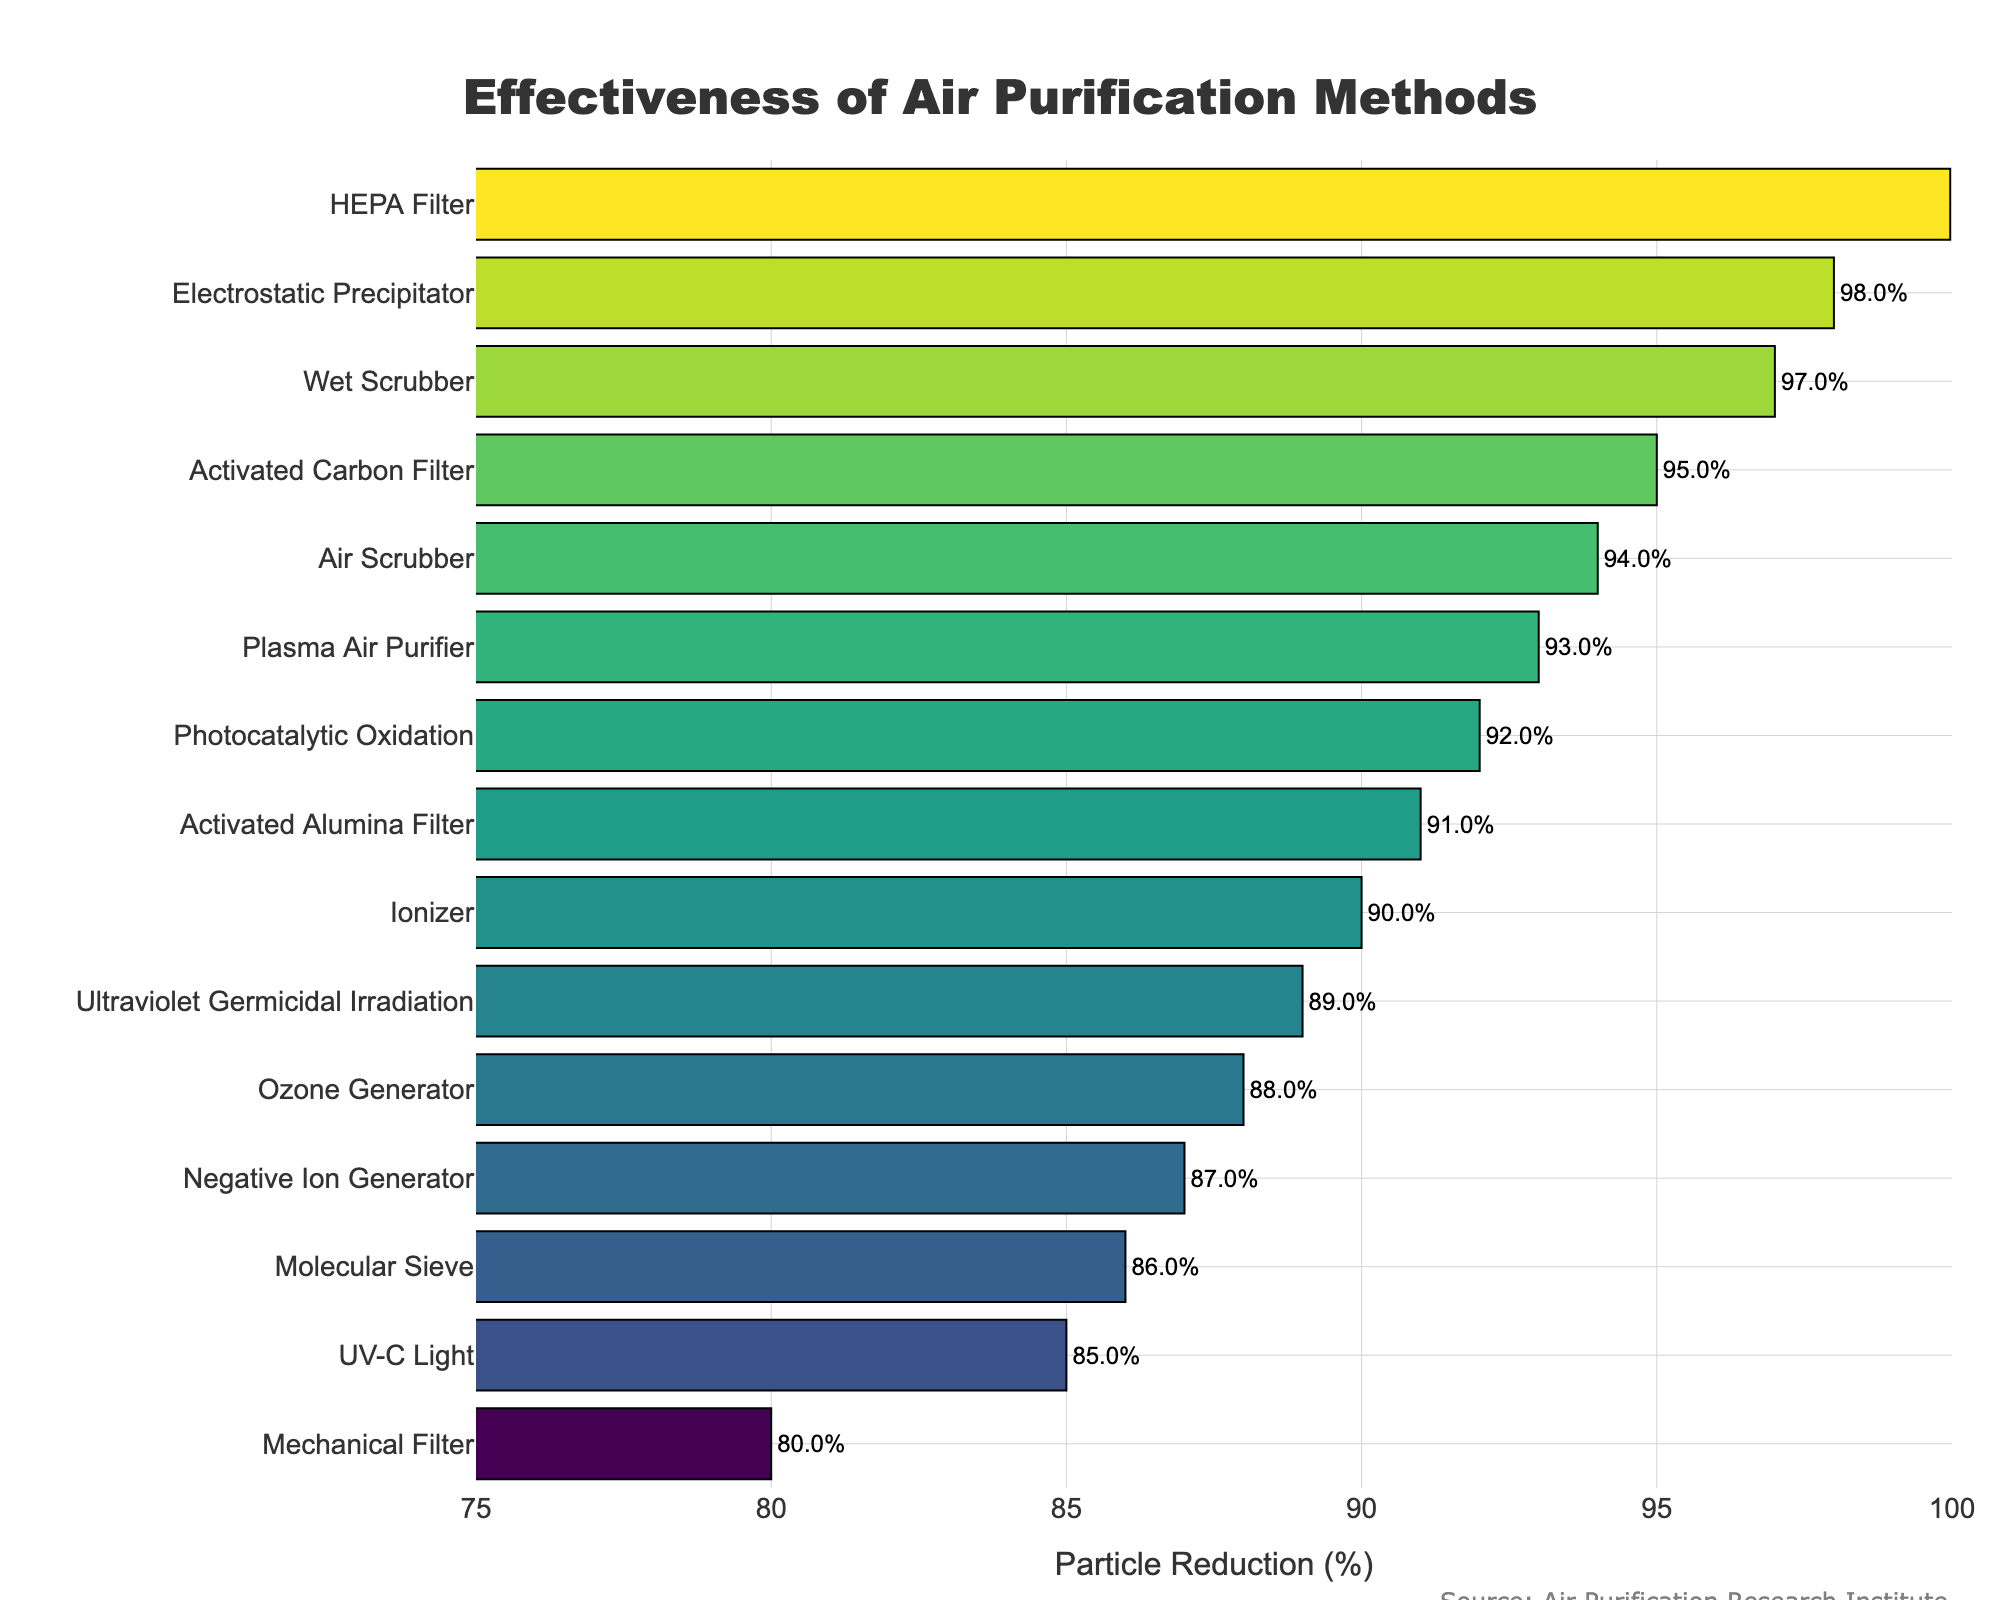What's the most effective air purification method for reducing smoke particles? The bar chart shows the percentage of particle reduction for various air purification methods. The bar corresponding to the HEPA filter reaches the highest value of 99.97%.
Answer: HEPA Filter Which air purification methods have a particle reduction percentage greater than 90%? By examining the bars in the chart that surpass the 90% mark, the methods are HEPA Filter, Activated Carbon Filter, Electrostatic Precipitator, Photocatalytic Oxidation, Plasma Air Purifier, UV-C Light, Wet Scrubber.
Answer: HEPA Filter, Activated Carbon Filter, Electrostatic Precipitator, Photocatalytic Oxidation, Plasma Air Purifier, UV-C Light, Wet Scrubber Compare the particle reduction percentage of the Plasma Air Purifier and UV-C Light. Which one is more effective? The bar for Plasma Air Purifier shows 93%, while the bar for UV-C Light shows 85%. Therefore, Plasma Air Purifier is more effective.
Answer: Plasma Air Purifier What is the difference in particle reduction percentage between the Ionizer and the Ozone Generator? The particle reduction percentage for the Ionizer is 90% and for the Ozone Generator is 88%. The difference between them is 90% - 88% = 2%.
Answer: 2% How many methods have a particle reduction percentage less than 85%? The bars corresponding to Mechanical Filter and Molecular Sieve are the only ones under 85%, specifically at 80% and 86%, respectively, but they are both above Mechanical Filter alone is under 85%.
Answer: 1 What's the average particle reduction percentage amongst the top five most effective methods? The top five effective methods are: HEPA Filter (99.97%), Electrostatic Precipitator (98%), Wet Scrubber (97%), Activated Carbon Filter (95%), Plasma Air Purifier (93%). The sum of their percentages is 99.97 + 98 + 97 + 95 + 93 = 482.97. The average is 482.97 / 5 = 96.594%.
Answer: 96.594% What's the least effective air purification method for reducing smoke particles? The smallest bar on the chart corresponds to the Mechanical Filter, with a particle reduction percentage of 80%.
Answer: Mechanical Filter Which is more effective: Activated Carbon Filter or Air Scrubber, and by how much? The bar for Activated Carbon Filter shows 95%, while the bar for Air Scrubber shows 94%. Activated Carbon Filter is more effective by 95% - 94% = 1%.
Answer: 1% What's the particle reduction percentage of Photocatalytic Oxidation? The bar corresponding to Photocatalytic Oxidation indicates a particle reduction percentage of 92%.
Answer: 92% Which methods are represented with bars exceeding the 88% mark but less than 95%? The methods fitting this criterion are: Plasma Air Purifier (93%), Photocatalytic Oxidation (92%), Activated Alumina Filter (91%), Ionizer (90%), Negative Ion Generator (87%), Ultraviolet Germicidal Irradiation (89%).
Answer: Plasma Air Purifier, Photocatalytic Oxidation, Activated Alumina Filter, Ionizer, Negative Ion Generator, Ultraviolet Germicidal Irradiation 